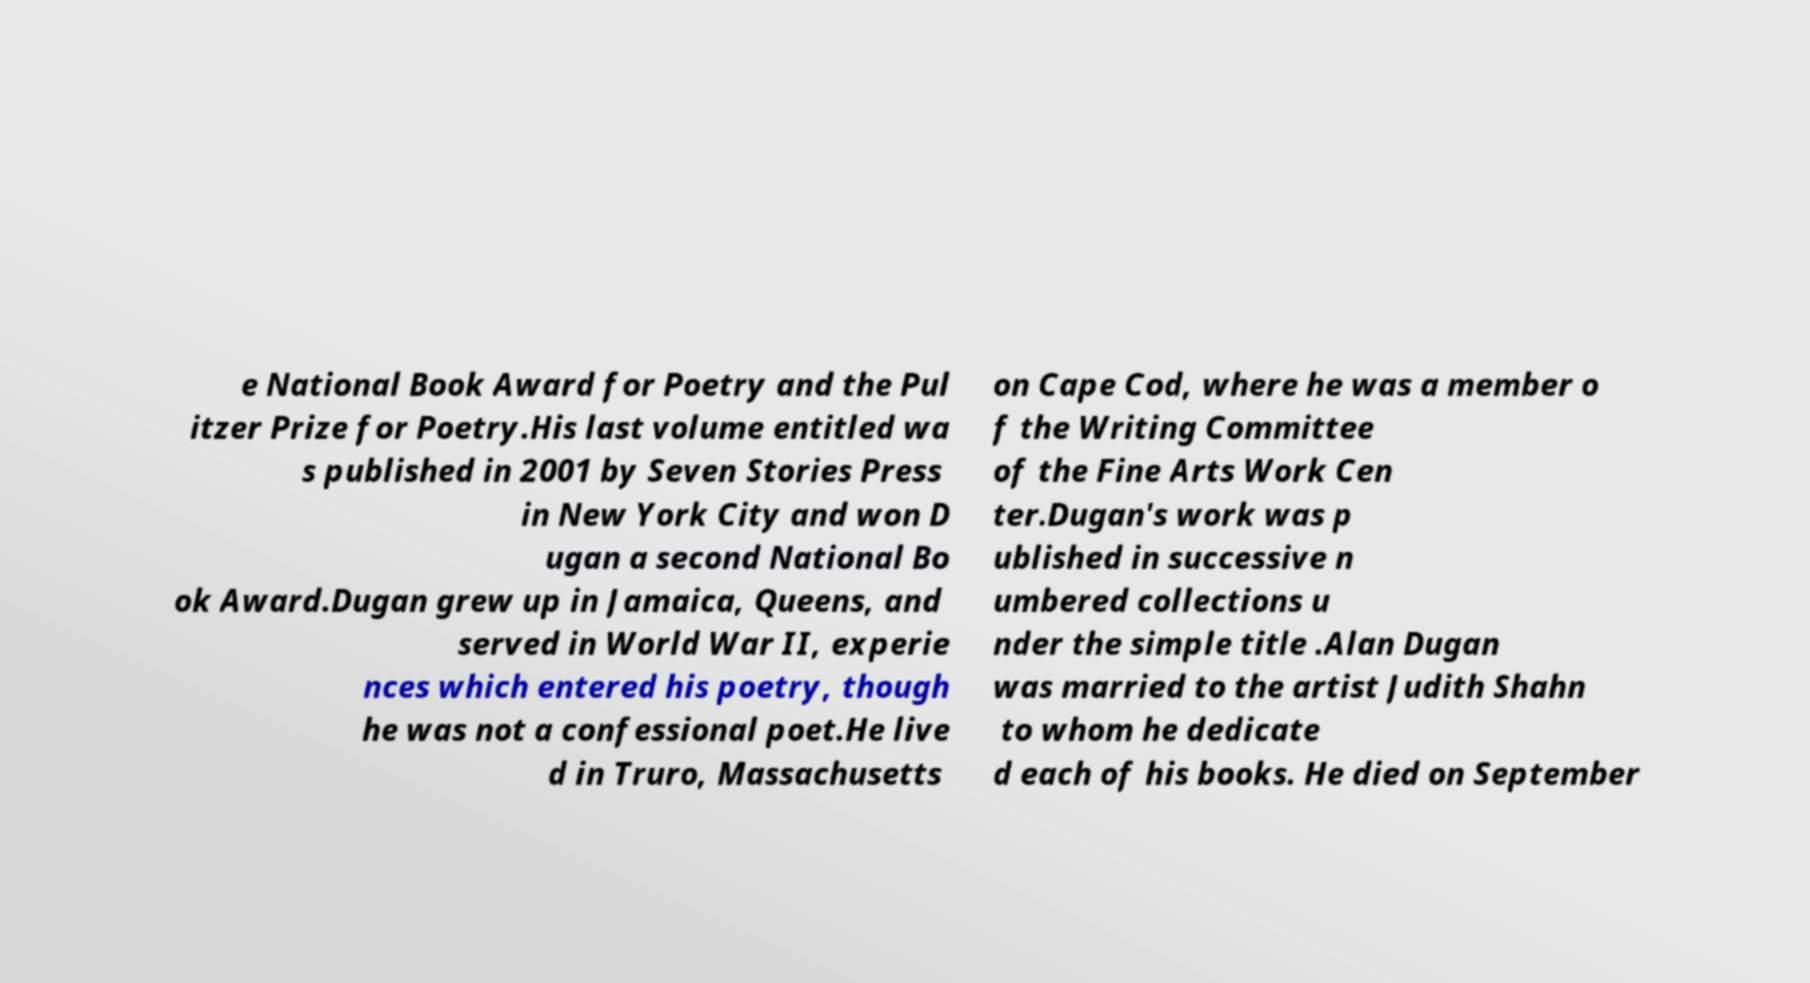Could you extract and type out the text from this image? e National Book Award for Poetry and the Pul itzer Prize for Poetry.His last volume entitled wa s published in 2001 by Seven Stories Press in New York City and won D ugan a second National Bo ok Award.Dugan grew up in Jamaica, Queens, and served in World War II, experie nces which entered his poetry, though he was not a confessional poet.He live d in Truro, Massachusetts on Cape Cod, where he was a member o f the Writing Committee of the Fine Arts Work Cen ter.Dugan's work was p ublished in successive n umbered collections u nder the simple title .Alan Dugan was married to the artist Judith Shahn to whom he dedicate d each of his books. He died on September 